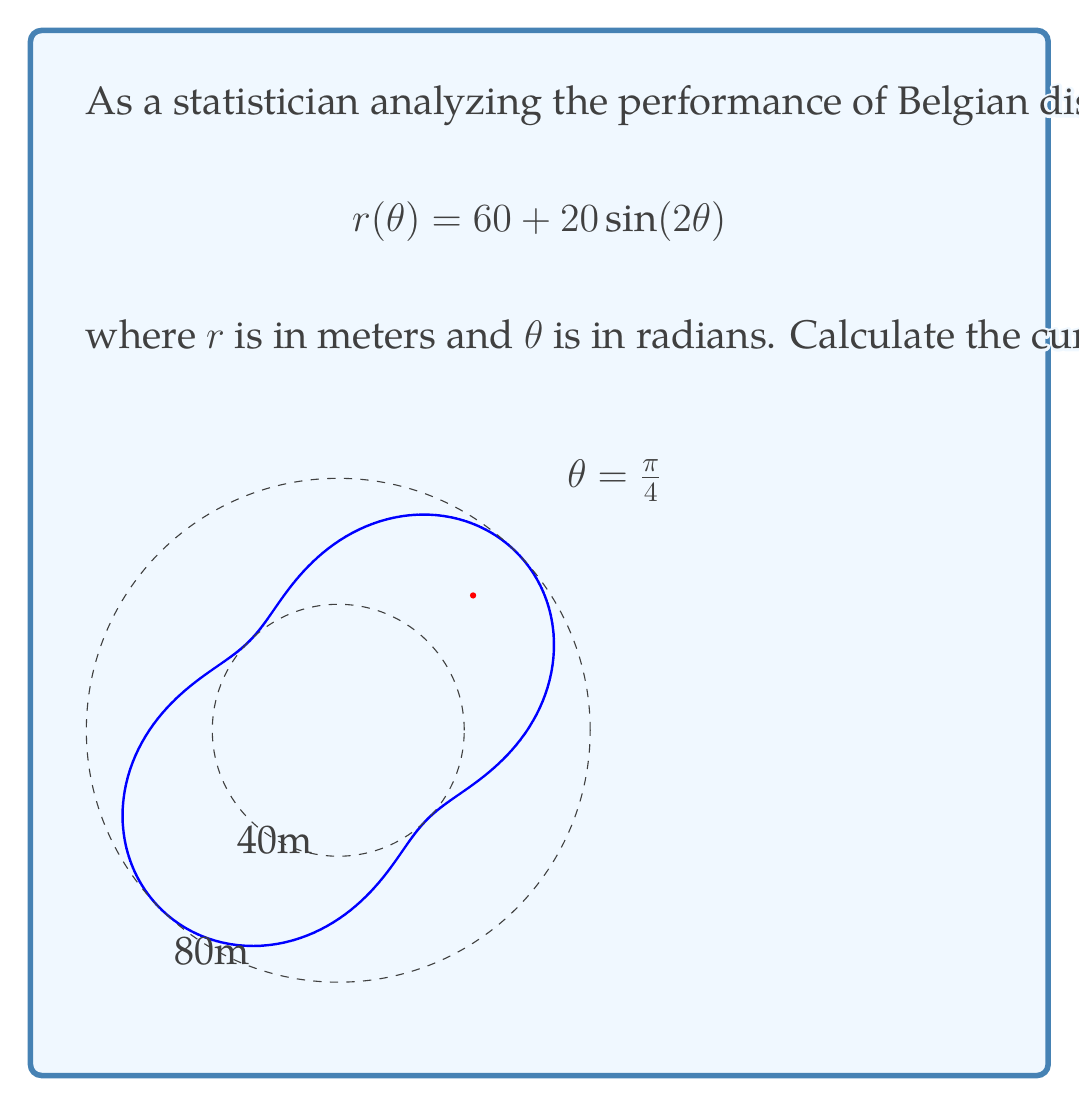Provide a solution to this math problem. To find the curvature $\kappa$ in polar coordinates, we use the formula:

$$\kappa = \frac{|r^2 + 2(r')^2 - rr''|}{(r^2 + (r')^2)^{3/2}}$$

where $r = r(\theta)$, $r' = \frac{dr}{d\theta}$, and $r'' = \frac{d^2r}{d\theta^2}$.

Step 1: Calculate $r$, $r'$, and $r''$
$r = 60 + 20\sin(2\theta)$
$r' = 40\cos(2\theta)$
$r'' = -80\sin(2\theta)$

Step 2: Evaluate at $\theta = \frac{\pi}{4}$
$r(\frac{\pi}{4}) = 60 + 20\sin(\frac{\pi}{2}) = 80$
$r'(\frac{\pi}{4}) = 40\cos(\frac{\pi}{2}) = 0$
$r''(\frac{\pi}{4}) = -80\sin(\frac{\pi}{2}) = -80$

Step 3: Substitute into the curvature formula
$$\kappa = \frac{|80^2 + 2(0)^2 - 80(-80)|}{(80^2 + 0^2)^{3/2}}$$

Step 4: Simplify
$$\kappa = \frac{|6400 + 6400|}{512000} = \frac{12800}{512000} = \frac{1}{40}$$

Therefore, the curvature at $\theta = \frac{\pi}{4}$ is $\frac{1}{40}$ m^(-1).
Answer: $\frac{1}{40}$ m^(-1) 